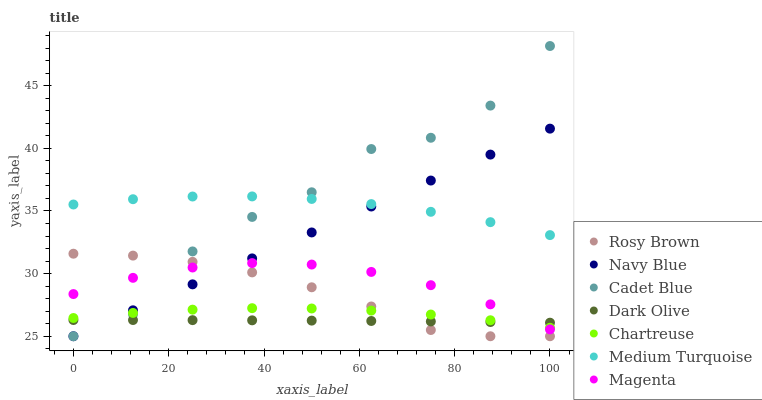Does Dark Olive have the minimum area under the curve?
Answer yes or no. Yes. Does Cadet Blue have the maximum area under the curve?
Answer yes or no. Yes. Does Navy Blue have the minimum area under the curve?
Answer yes or no. No. Does Navy Blue have the maximum area under the curve?
Answer yes or no. No. Is Navy Blue the smoothest?
Answer yes or no. Yes. Is Cadet Blue the roughest?
Answer yes or no. Yes. Is Dark Olive the smoothest?
Answer yes or no. No. Is Dark Olive the roughest?
Answer yes or no. No. Does Cadet Blue have the lowest value?
Answer yes or no. Yes. Does Dark Olive have the lowest value?
Answer yes or no. No. Does Cadet Blue have the highest value?
Answer yes or no. Yes. Does Navy Blue have the highest value?
Answer yes or no. No. Is Rosy Brown less than Medium Turquoise?
Answer yes or no. Yes. Is Medium Turquoise greater than Dark Olive?
Answer yes or no. Yes. Does Magenta intersect Dark Olive?
Answer yes or no. Yes. Is Magenta less than Dark Olive?
Answer yes or no. No. Is Magenta greater than Dark Olive?
Answer yes or no. No. Does Rosy Brown intersect Medium Turquoise?
Answer yes or no. No. 